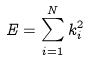Convert formula to latex. <formula><loc_0><loc_0><loc_500><loc_500>E = \sum _ { i = 1 } ^ { N } k _ { i } ^ { 2 }</formula> 